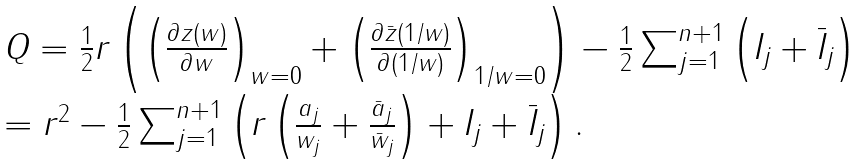Convert formula to latex. <formula><loc_0><loc_0><loc_500><loc_500>\begin{array} { l } Q = \frac { 1 } { 2 } r \left ( \left ( \frac { \partial z ( w ) } { \partial w } \right ) _ { w = 0 } + \left ( \frac { \partial \bar { z } ( 1 / w ) } { \partial ( 1 / w ) } \right ) _ { 1 / w = 0 } \right ) - \frac { 1 } { 2 } \sum _ { j = 1 } ^ { n + 1 } \left ( I _ { j } + \bar { I } _ { j } \right ) \\ = r ^ { 2 } - \frac { 1 } { 2 } \sum _ { j = 1 } ^ { n + 1 } \left ( r \left ( \frac { a _ { j } } { w _ { j } } + \frac { \bar { a } _ { j } } { \bar { w } _ { j } } \right ) + I _ { j } + \bar { I } _ { j } \right ) . \end{array}</formula> 